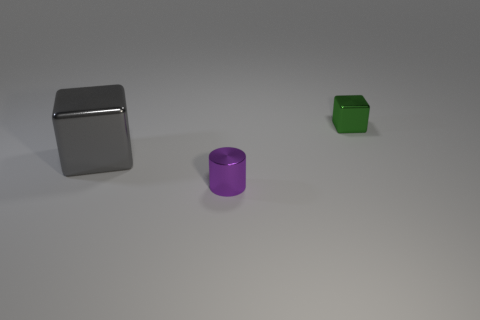Is there any other thing that is the same size as the purple thing?
Your answer should be compact. Yes. Are there any large gray cubes left of the tiny object that is in front of the tiny metal thing behind the tiny purple cylinder?
Your response must be concise. Yes. There is a cube that is the same size as the purple object; what color is it?
Offer a terse response. Green. What is the shape of the thing that is to the left of the small metal cube and right of the large cube?
Ensure brevity in your answer.  Cylinder. What size is the thing that is in front of the cube that is on the left side of the tiny purple shiny cylinder?
Offer a very short reply. Small. What number of small cylinders have the same color as the big block?
Ensure brevity in your answer.  0. How many other things are there of the same size as the shiny cylinder?
Your response must be concise. 1. There is a metallic thing that is both in front of the tiny green block and right of the large gray object; how big is it?
Provide a short and direct response. Small. What number of small objects have the same shape as the big gray object?
Provide a succinct answer. 1. What material is the big cube?
Provide a short and direct response. Metal. 